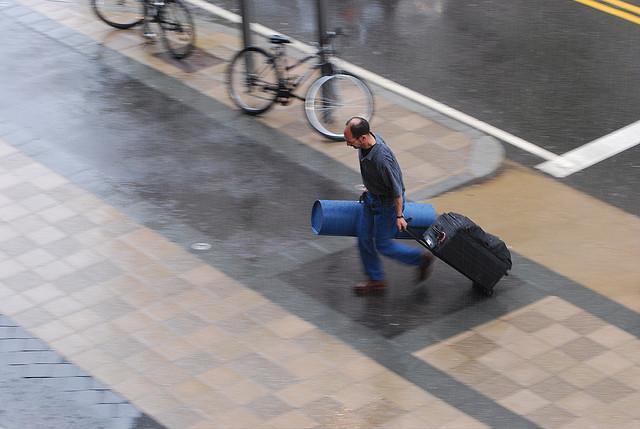How many bicycles are shown?
Give a very brief answer. 2. How many bicycles are in the picture?
Give a very brief answer. 2. How many airplanes can you see?
Give a very brief answer. 0. 